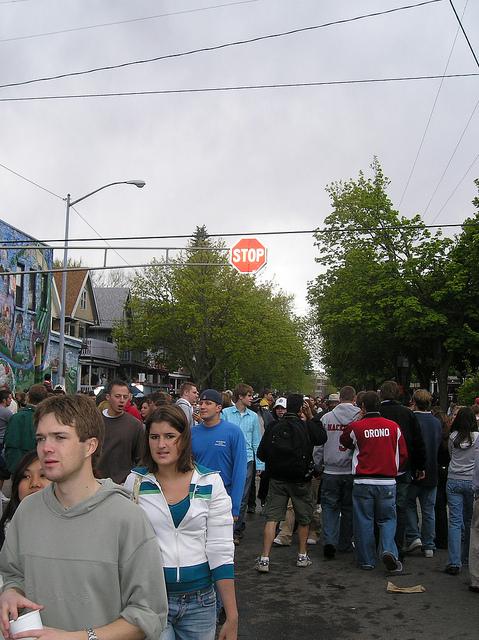Why is the lady clutching her purse?
Be succinct. Safety. Is that a go sign?
Be succinct. No. Are these people standing on a wide sidewalk or in the street?
Concise answer only. Street. How many street lights can be seen?
Quick response, please. 1. Is anyone facing the camera?
Be succinct. Yes. 